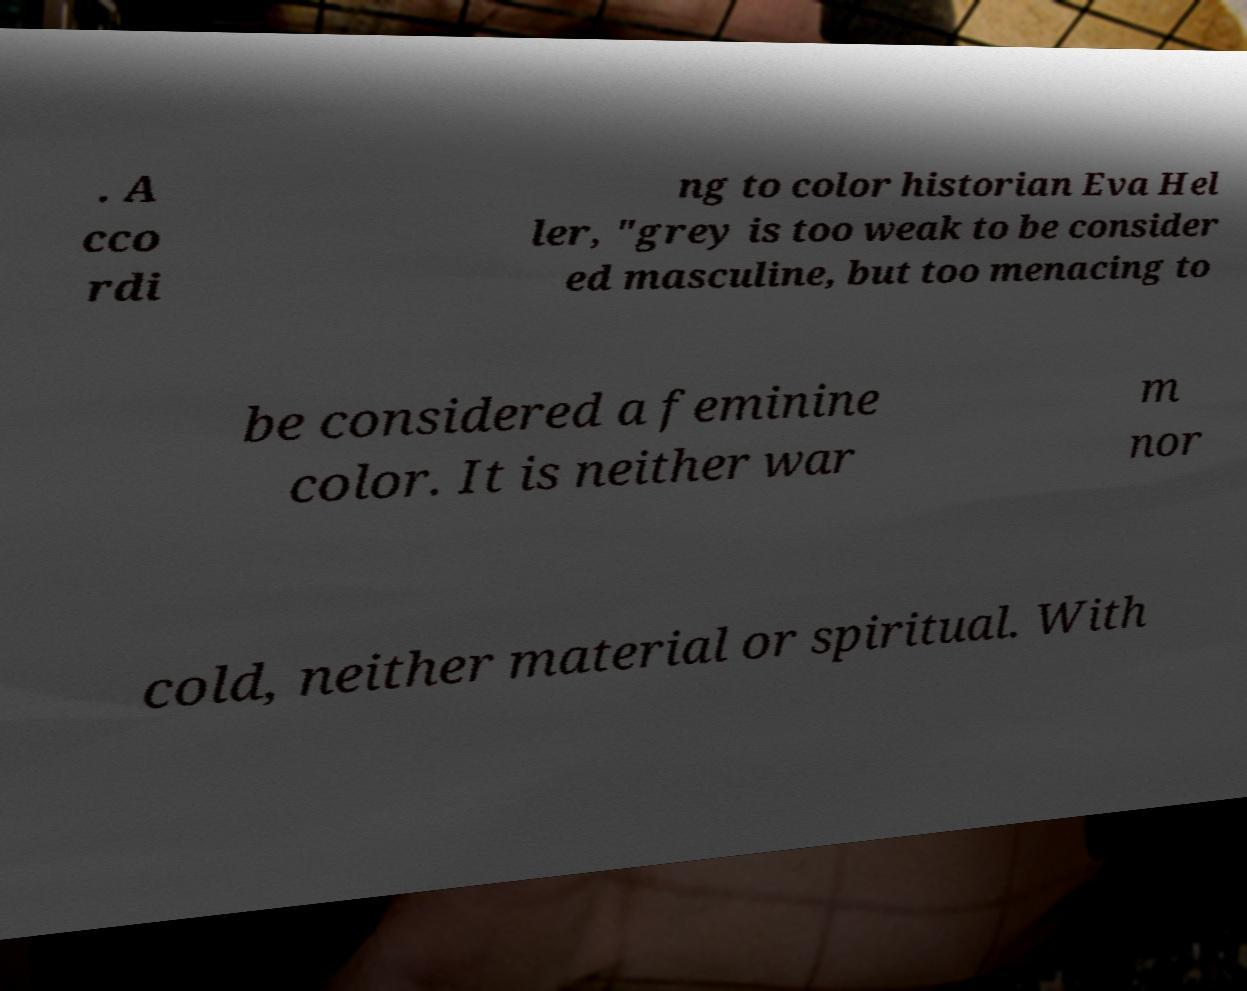There's text embedded in this image that I need extracted. Can you transcribe it verbatim? . A cco rdi ng to color historian Eva Hel ler, "grey is too weak to be consider ed masculine, but too menacing to be considered a feminine color. It is neither war m nor cold, neither material or spiritual. With 